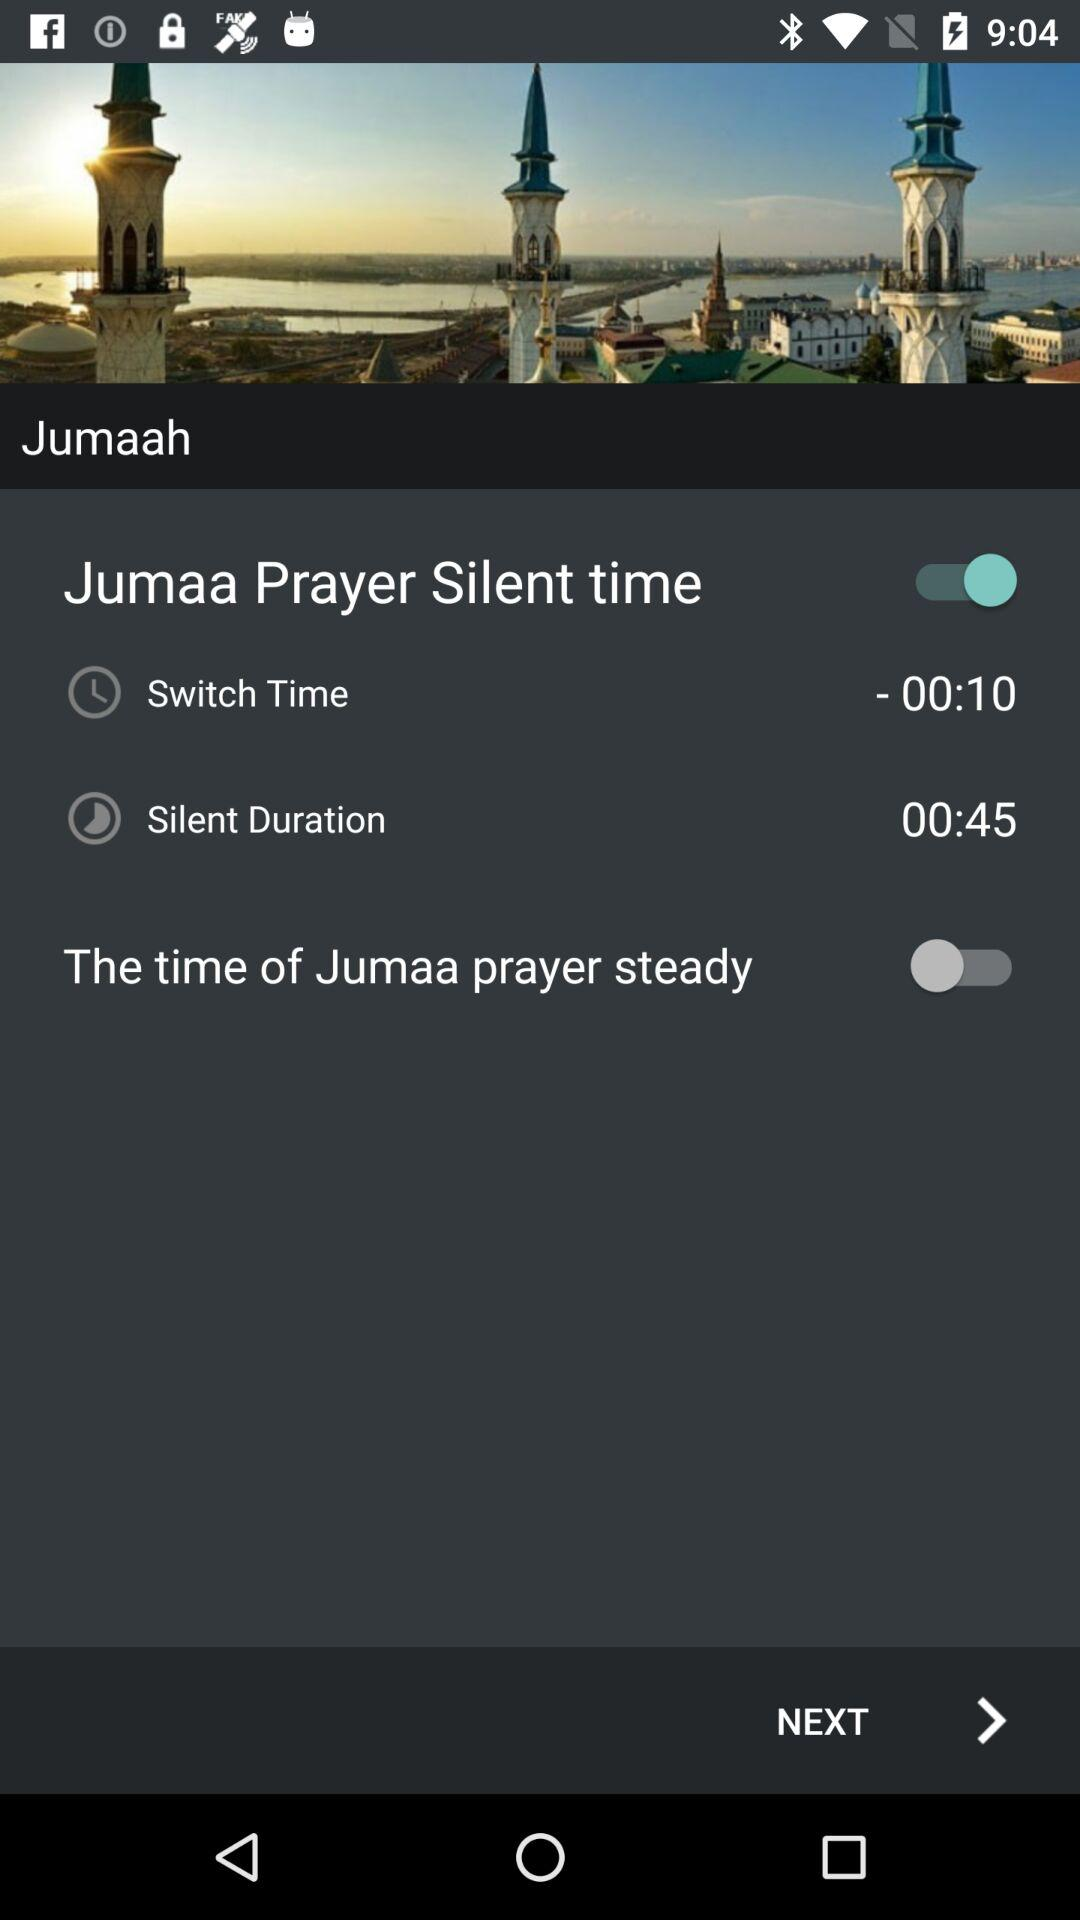What is the status of "The time of Jumaa prayer steady"? The status is "off". 